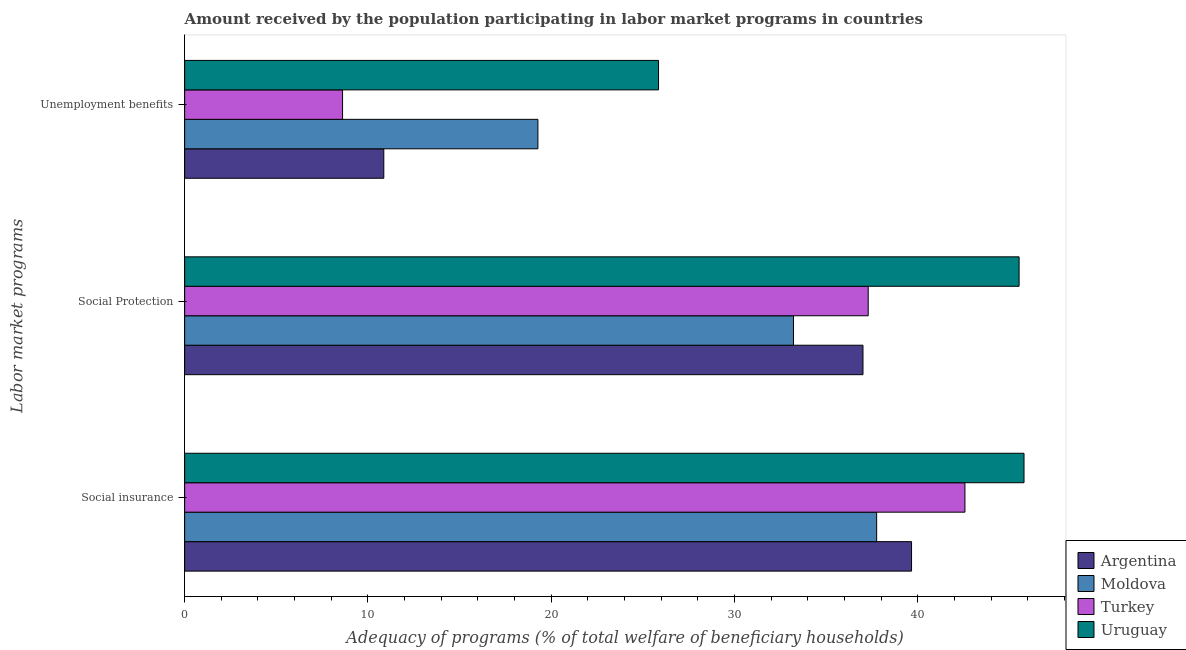How many different coloured bars are there?
Your answer should be very brief. 4. How many groups of bars are there?
Your answer should be compact. 3. Are the number of bars per tick equal to the number of legend labels?
Your response must be concise. Yes. Are the number of bars on each tick of the Y-axis equal?
Make the answer very short. Yes. How many bars are there on the 1st tick from the bottom?
Make the answer very short. 4. What is the label of the 2nd group of bars from the top?
Offer a terse response. Social Protection. What is the amount received by the population participating in unemployment benefits programs in Moldova?
Offer a terse response. 19.28. Across all countries, what is the maximum amount received by the population participating in unemployment benefits programs?
Keep it short and to the point. 25.86. Across all countries, what is the minimum amount received by the population participating in unemployment benefits programs?
Offer a very short reply. 8.62. In which country was the amount received by the population participating in social protection programs maximum?
Your answer should be very brief. Uruguay. In which country was the amount received by the population participating in social protection programs minimum?
Provide a succinct answer. Moldova. What is the total amount received by the population participating in social insurance programs in the graph?
Offer a terse response. 165.8. What is the difference between the amount received by the population participating in social insurance programs in Uruguay and that in Turkey?
Your answer should be compact. 3.22. What is the difference between the amount received by the population participating in social protection programs in Moldova and the amount received by the population participating in unemployment benefits programs in Uruguay?
Ensure brevity in your answer.  7.36. What is the average amount received by the population participating in unemployment benefits programs per country?
Give a very brief answer. 16.15. What is the difference between the amount received by the population participating in social insurance programs and amount received by the population participating in unemployment benefits programs in Argentina?
Keep it short and to the point. 28.8. In how many countries, is the amount received by the population participating in unemployment benefits programs greater than 28 %?
Make the answer very short. 0. What is the ratio of the amount received by the population participating in social protection programs in Argentina to that in Turkey?
Keep it short and to the point. 0.99. What is the difference between the highest and the second highest amount received by the population participating in social protection programs?
Make the answer very short. 8.23. What is the difference between the highest and the lowest amount received by the population participating in social protection programs?
Your answer should be very brief. 12.31. Is the sum of the amount received by the population participating in social protection programs in Turkey and Uruguay greater than the maximum amount received by the population participating in social insurance programs across all countries?
Your answer should be very brief. Yes. What does the 4th bar from the top in Social insurance represents?
Make the answer very short. Argentina. Is it the case that in every country, the sum of the amount received by the population participating in social insurance programs and amount received by the population participating in social protection programs is greater than the amount received by the population participating in unemployment benefits programs?
Your answer should be very brief. Yes. How many bars are there?
Give a very brief answer. 12. Does the graph contain any zero values?
Offer a terse response. No. Does the graph contain grids?
Give a very brief answer. No. Where does the legend appear in the graph?
Provide a short and direct response. Bottom right. How many legend labels are there?
Provide a short and direct response. 4. What is the title of the graph?
Your answer should be very brief. Amount received by the population participating in labor market programs in countries. What is the label or title of the X-axis?
Your answer should be compact. Adequacy of programs (% of total welfare of beneficiary households). What is the label or title of the Y-axis?
Make the answer very short. Labor market programs. What is the Adequacy of programs (% of total welfare of beneficiary households) of Argentina in Social insurance?
Your response must be concise. 39.66. What is the Adequacy of programs (% of total welfare of beneficiary households) in Moldova in Social insurance?
Provide a short and direct response. 37.76. What is the Adequacy of programs (% of total welfare of beneficiary households) in Turkey in Social insurance?
Your response must be concise. 42.58. What is the Adequacy of programs (% of total welfare of beneficiary households) of Uruguay in Social insurance?
Your answer should be compact. 45.8. What is the Adequacy of programs (% of total welfare of beneficiary households) of Argentina in Social Protection?
Ensure brevity in your answer.  37.01. What is the Adequacy of programs (% of total welfare of beneficiary households) in Moldova in Social Protection?
Ensure brevity in your answer.  33.22. What is the Adequacy of programs (% of total welfare of beneficiary households) in Turkey in Social Protection?
Keep it short and to the point. 37.3. What is the Adequacy of programs (% of total welfare of beneficiary households) of Uruguay in Social Protection?
Your answer should be compact. 45.53. What is the Adequacy of programs (% of total welfare of beneficiary households) in Argentina in Unemployment benefits?
Offer a very short reply. 10.87. What is the Adequacy of programs (% of total welfare of beneficiary households) of Moldova in Unemployment benefits?
Make the answer very short. 19.28. What is the Adequacy of programs (% of total welfare of beneficiary households) of Turkey in Unemployment benefits?
Offer a very short reply. 8.62. What is the Adequacy of programs (% of total welfare of beneficiary households) in Uruguay in Unemployment benefits?
Your answer should be compact. 25.86. Across all Labor market programs, what is the maximum Adequacy of programs (% of total welfare of beneficiary households) in Argentina?
Provide a succinct answer. 39.66. Across all Labor market programs, what is the maximum Adequacy of programs (% of total welfare of beneficiary households) of Moldova?
Provide a short and direct response. 37.76. Across all Labor market programs, what is the maximum Adequacy of programs (% of total welfare of beneficiary households) of Turkey?
Provide a succinct answer. 42.58. Across all Labor market programs, what is the maximum Adequacy of programs (% of total welfare of beneficiary households) of Uruguay?
Ensure brevity in your answer.  45.8. Across all Labor market programs, what is the minimum Adequacy of programs (% of total welfare of beneficiary households) in Argentina?
Keep it short and to the point. 10.87. Across all Labor market programs, what is the minimum Adequacy of programs (% of total welfare of beneficiary households) of Moldova?
Your response must be concise. 19.28. Across all Labor market programs, what is the minimum Adequacy of programs (% of total welfare of beneficiary households) in Turkey?
Make the answer very short. 8.62. Across all Labor market programs, what is the minimum Adequacy of programs (% of total welfare of beneficiary households) of Uruguay?
Keep it short and to the point. 25.86. What is the total Adequacy of programs (% of total welfare of beneficiary households) in Argentina in the graph?
Your response must be concise. 87.54. What is the total Adequacy of programs (% of total welfare of beneficiary households) of Moldova in the graph?
Make the answer very short. 90.26. What is the total Adequacy of programs (% of total welfare of beneficiary households) in Turkey in the graph?
Your response must be concise. 88.49. What is the total Adequacy of programs (% of total welfare of beneficiary households) of Uruguay in the graph?
Your answer should be compact. 117.19. What is the difference between the Adequacy of programs (% of total welfare of beneficiary households) in Argentina in Social insurance and that in Social Protection?
Provide a succinct answer. 2.65. What is the difference between the Adequacy of programs (% of total welfare of beneficiary households) in Moldova in Social insurance and that in Social Protection?
Your answer should be compact. 4.54. What is the difference between the Adequacy of programs (% of total welfare of beneficiary households) of Turkey in Social insurance and that in Social Protection?
Ensure brevity in your answer.  5.28. What is the difference between the Adequacy of programs (% of total welfare of beneficiary households) in Uruguay in Social insurance and that in Social Protection?
Give a very brief answer. 0.27. What is the difference between the Adequacy of programs (% of total welfare of beneficiary households) in Argentina in Social insurance and that in Unemployment benefits?
Your answer should be very brief. 28.8. What is the difference between the Adequacy of programs (% of total welfare of beneficiary households) of Moldova in Social insurance and that in Unemployment benefits?
Offer a very short reply. 18.48. What is the difference between the Adequacy of programs (% of total welfare of beneficiary households) in Turkey in Social insurance and that in Unemployment benefits?
Make the answer very short. 33.96. What is the difference between the Adequacy of programs (% of total welfare of beneficiary households) of Uruguay in Social insurance and that in Unemployment benefits?
Your answer should be very brief. 19.94. What is the difference between the Adequacy of programs (% of total welfare of beneficiary households) in Argentina in Social Protection and that in Unemployment benefits?
Your answer should be compact. 26.15. What is the difference between the Adequacy of programs (% of total welfare of beneficiary households) of Moldova in Social Protection and that in Unemployment benefits?
Your answer should be compact. 13.95. What is the difference between the Adequacy of programs (% of total welfare of beneficiary households) in Turkey in Social Protection and that in Unemployment benefits?
Provide a succinct answer. 28.68. What is the difference between the Adequacy of programs (% of total welfare of beneficiary households) of Uruguay in Social Protection and that in Unemployment benefits?
Provide a succinct answer. 19.67. What is the difference between the Adequacy of programs (% of total welfare of beneficiary households) in Argentina in Social insurance and the Adequacy of programs (% of total welfare of beneficiary households) in Moldova in Social Protection?
Provide a succinct answer. 6.44. What is the difference between the Adequacy of programs (% of total welfare of beneficiary households) in Argentina in Social insurance and the Adequacy of programs (% of total welfare of beneficiary households) in Turkey in Social Protection?
Make the answer very short. 2.37. What is the difference between the Adequacy of programs (% of total welfare of beneficiary households) in Argentina in Social insurance and the Adequacy of programs (% of total welfare of beneficiary households) in Uruguay in Social Protection?
Your answer should be very brief. -5.87. What is the difference between the Adequacy of programs (% of total welfare of beneficiary households) of Moldova in Social insurance and the Adequacy of programs (% of total welfare of beneficiary households) of Turkey in Social Protection?
Your answer should be compact. 0.46. What is the difference between the Adequacy of programs (% of total welfare of beneficiary households) in Moldova in Social insurance and the Adequacy of programs (% of total welfare of beneficiary households) in Uruguay in Social Protection?
Offer a very short reply. -7.77. What is the difference between the Adequacy of programs (% of total welfare of beneficiary households) in Turkey in Social insurance and the Adequacy of programs (% of total welfare of beneficiary households) in Uruguay in Social Protection?
Keep it short and to the point. -2.95. What is the difference between the Adequacy of programs (% of total welfare of beneficiary households) of Argentina in Social insurance and the Adequacy of programs (% of total welfare of beneficiary households) of Moldova in Unemployment benefits?
Your answer should be very brief. 20.39. What is the difference between the Adequacy of programs (% of total welfare of beneficiary households) in Argentina in Social insurance and the Adequacy of programs (% of total welfare of beneficiary households) in Turkey in Unemployment benefits?
Offer a very short reply. 31.05. What is the difference between the Adequacy of programs (% of total welfare of beneficiary households) in Argentina in Social insurance and the Adequacy of programs (% of total welfare of beneficiary households) in Uruguay in Unemployment benefits?
Offer a very short reply. 13.81. What is the difference between the Adequacy of programs (% of total welfare of beneficiary households) in Moldova in Social insurance and the Adequacy of programs (% of total welfare of beneficiary households) in Turkey in Unemployment benefits?
Your response must be concise. 29.14. What is the difference between the Adequacy of programs (% of total welfare of beneficiary households) in Moldova in Social insurance and the Adequacy of programs (% of total welfare of beneficiary households) in Uruguay in Unemployment benefits?
Keep it short and to the point. 11.9. What is the difference between the Adequacy of programs (% of total welfare of beneficiary households) in Turkey in Social insurance and the Adequacy of programs (% of total welfare of beneficiary households) in Uruguay in Unemployment benefits?
Your response must be concise. 16.72. What is the difference between the Adequacy of programs (% of total welfare of beneficiary households) of Argentina in Social Protection and the Adequacy of programs (% of total welfare of beneficiary households) of Moldova in Unemployment benefits?
Offer a terse response. 17.74. What is the difference between the Adequacy of programs (% of total welfare of beneficiary households) of Argentina in Social Protection and the Adequacy of programs (% of total welfare of beneficiary households) of Turkey in Unemployment benefits?
Your answer should be very brief. 28.4. What is the difference between the Adequacy of programs (% of total welfare of beneficiary households) of Argentina in Social Protection and the Adequacy of programs (% of total welfare of beneficiary households) of Uruguay in Unemployment benefits?
Ensure brevity in your answer.  11.16. What is the difference between the Adequacy of programs (% of total welfare of beneficiary households) in Moldova in Social Protection and the Adequacy of programs (% of total welfare of beneficiary households) in Turkey in Unemployment benefits?
Keep it short and to the point. 24.6. What is the difference between the Adequacy of programs (% of total welfare of beneficiary households) in Moldova in Social Protection and the Adequacy of programs (% of total welfare of beneficiary households) in Uruguay in Unemployment benefits?
Your answer should be compact. 7.36. What is the difference between the Adequacy of programs (% of total welfare of beneficiary households) of Turkey in Social Protection and the Adequacy of programs (% of total welfare of beneficiary households) of Uruguay in Unemployment benefits?
Your response must be concise. 11.44. What is the average Adequacy of programs (% of total welfare of beneficiary households) in Argentina per Labor market programs?
Your response must be concise. 29.18. What is the average Adequacy of programs (% of total welfare of beneficiary households) in Moldova per Labor market programs?
Your response must be concise. 30.09. What is the average Adequacy of programs (% of total welfare of beneficiary households) in Turkey per Labor market programs?
Your answer should be compact. 29.5. What is the average Adequacy of programs (% of total welfare of beneficiary households) in Uruguay per Labor market programs?
Provide a short and direct response. 39.06. What is the difference between the Adequacy of programs (% of total welfare of beneficiary households) of Argentina and Adequacy of programs (% of total welfare of beneficiary households) of Moldova in Social insurance?
Offer a terse response. 1.9. What is the difference between the Adequacy of programs (% of total welfare of beneficiary households) in Argentina and Adequacy of programs (% of total welfare of beneficiary households) in Turkey in Social insurance?
Your answer should be compact. -2.91. What is the difference between the Adequacy of programs (% of total welfare of beneficiary households) in Argentina and Adequacy of programs (% of total welfare of beneficiary households) in Uruguay in Social insurance?
Keep it short and to the point. -6.14. What is the difference between the Adequacy of programs (% of total welfare of beneficiary households) of Moldova and Adequacy of programs (% of total welfare of beneficiary households) of Turkey in Social insurance?
Your answer should be compact. -4.82. What is the difference between the Adequacy of programs (% of total welfare of beneficiary households) in Moldova and Adequacy of programs (% of total welfare of beneficiary households) in Uruguay in Social insurance?
Your answer should be very brief. -8.04. What is the difference between the Adequacy of programs (% of total welfare of beneficiary households) in Turkey and Adequacy of programs (% of total welfare of beneficiary households) in Uruguay in Social insurance?
Provide a succinct answer. -3.22. What is the difference between the Adequacy of programs (% of total welfare of beneficiary households) in Argentina and Adequacy of programs (% of total welfare of beneficiary households) in Moldova in Social Protection?
Offer a terse response. 3.79. What is the difference between the Adequacy of programs (% of total welfare of beneficiary households) of Argentina and Adequacy of programs (% of total welfare of beneficiary households) of Turkey in Social Protection?
Your response must be concise. -0.28. What is the difference between the Adequacy of programs (% of total welfare of beneficiary households) in Argentina and Adequacy of programs (% of total welfare of beneficiary households) in Uruguay in Social Protection?
Keep it short and to the point. -8.52. What is the difference between the Adequacy of programs (% of total welfare of beneficiary households) of Moldova and Adequacy of programs (% of total welfare of beneficiary households) of Turkey in Social Protection?
Give a very brief answer. -4.08. What is the difference between the Adequacy of programs (% of total welfare of beneficiary households) of Moldova and Adequacy of programs (% of total welfare of beneficiary households) of Uruguay in Social Protection?
Your response must be concise. -12.31. What is the difference between the Adequacy of programs (% of total welfare of beneficiary households) of Turkey and Adequacy of programs (% of total welfare of beneficiary households) of Uruguay in Social Protection?
Provide a short and direct response. -8.23. What is the difference between the Adequacy of programs (% of total welfare of beneficiary households) of Argentina and Adequacy of programs (% of total welfare of beneficiary households) of Moldova in Unemployment benefits?
Provide a succinct answer. -8.41. What is the difference between the Adequacy of programs (% of total welfare of beneficiary households) of Argentina and Adequacy of programs (% of total welfare of beneficiary households) of Turkey in Unemployment benefits?
Provide a short and direct response. 2.25. What is the difference between the Adequacy of programs (% of total welfare of beneficiary households) in Argentina and Adequacy of programs (% of total welfare of beneficiary households) in Uruguay in Unemployment benefits?
Your answer should be compact. -14.99. What is the difference between the Adequacy of programs (% of total welfare of beneficiary households) of Moldova and Adequacy of programs (% of total welfare of beneficiary households) of Turkey in Unemployment benefits?
Offer a very short reply. 10.66. What is the difference between the Adequacy of programs (% of total welfare of beneficiary households) of Moldova and Adequacy of programs (% of total welfare of beneficiary households) of Uruguay in Unemployment benefits?
Give a very brief answer. -6.58. What is the difference between the Adequacy of programs (% of total welfare of beneficiary households) of Turkey and Adequacy of programs (% of total welfare of beneficiary households) of Uruguay in Unemployment benefits?
Ensure brevity in your answer.  -17.24. What is the ratio of the Adequacy of programs (% of total welfare of beneficiary households) of Argentina in Social insurance to that in Social Protection?
Your answer should be very brief. 1.07. What is the ratio of the Adequacy of programs (% of total welfare of beneficiary households) in Moldova in Social insurance to that in Social Protection?
Give a very brief answer. 1.14. What is the ratio of the Adequacy of programs (% of total welfare of beneficiary households) in Turkey in Social insurance to that in Social Protection?
Give a very brief answer. 1.14. What is the ratio of the Adequacy of programs (% of total welfare of beneficiary households) in Uruguay in Social insurance to that in Social Protection?
Provide a short and direct response. 1.01. What is the ratio of the Adequacy of programs (% of total welfare of beneficiary households) of Argentina in Social insurance to that in Unemployment benefits?
Keep it short and to the point. 3.65. What is the ratio of the Adequacy of programs (% of total welfare of beneficiary households) in Moldova in Social insurance to that in Unemployment benefits?
Provide a short and direct response. 1.96. What is the ratio of the Adequacy of programs (% of total welfare of beneficiary households) in Turkey in Social insurance to that in Unemployment benefits?
Your answer should be very brief. 4.94. What is the ratio of the Adequacy of programs (% of total welfare of beneficiary households) of Uruguay in Social insurance to that in Unemployment benefits?
Offer a very short reply. 1.77. What is the ratio of the Adequacy of programs (% of total welfare of beneficiary households) in Argentina in Social Protection to that in Unemployment benefits?
Provide a succinct answer. 3.41. What is the ratio of the Adequacy of programs (% of total welfare of beneficiary households) in Moldova in Social Protection to that in Unemployment benefits?
Your response must be concise. 1.72. What is the ratio of the Adequacy of programs (% of total welfare of beneficiary households) in Turkey in Social Protection to that in Unemployment benefits?
Keep it short and to the point. 4.33. What is the ratio of the Adequacy of programs (% of total welfare of beneficiary households) in Uruguay in Social Protection to that in Unemployment benefits?
Your answer should be compact. 1.76. What is the difference between the highest and the second highest Adequacy of programs (% of total welfare of beneficiary households) of Argentina?
Make the answer very short. 2.65. What is the difference between the highest and the second highest Adequacy of programs (% of total welfare of beneficiary households) in Moldova?
Provide a short and direct response. 4.54. What is the difference between the highest and the second highest Adequacy of programs (% of total welfare of beneficiary households) in Turkey?
Your response must be concise. 5.28. What is the difference between the highest and the second highest Adequacy of programs (% of total welfare of beneficiary households) of Uruguay?
Give a very brief answer. 0.27. What is the difference between the highest and the lowest Adequacy of programs (% of total welfare of beneficiary households) of Argentina?
Your answer should be very brief. 28.8. What is the difference between the highest and the lowest Adequacy of programs (% of total welfare of beneficiary households) of Moldova?
Ensure brevity in your answer.  18.48. What is the difference between the highest and the lowest Adequacy of programs (% of total welfare of beneficiary households) in Turkey?
Provide a short and direct response. 33.96. What is the difference between the highest and the lowest Adequacy of programs (% of total welfare of beneficiary households) of Uruguay?
Make the answer very short. 19.94. 